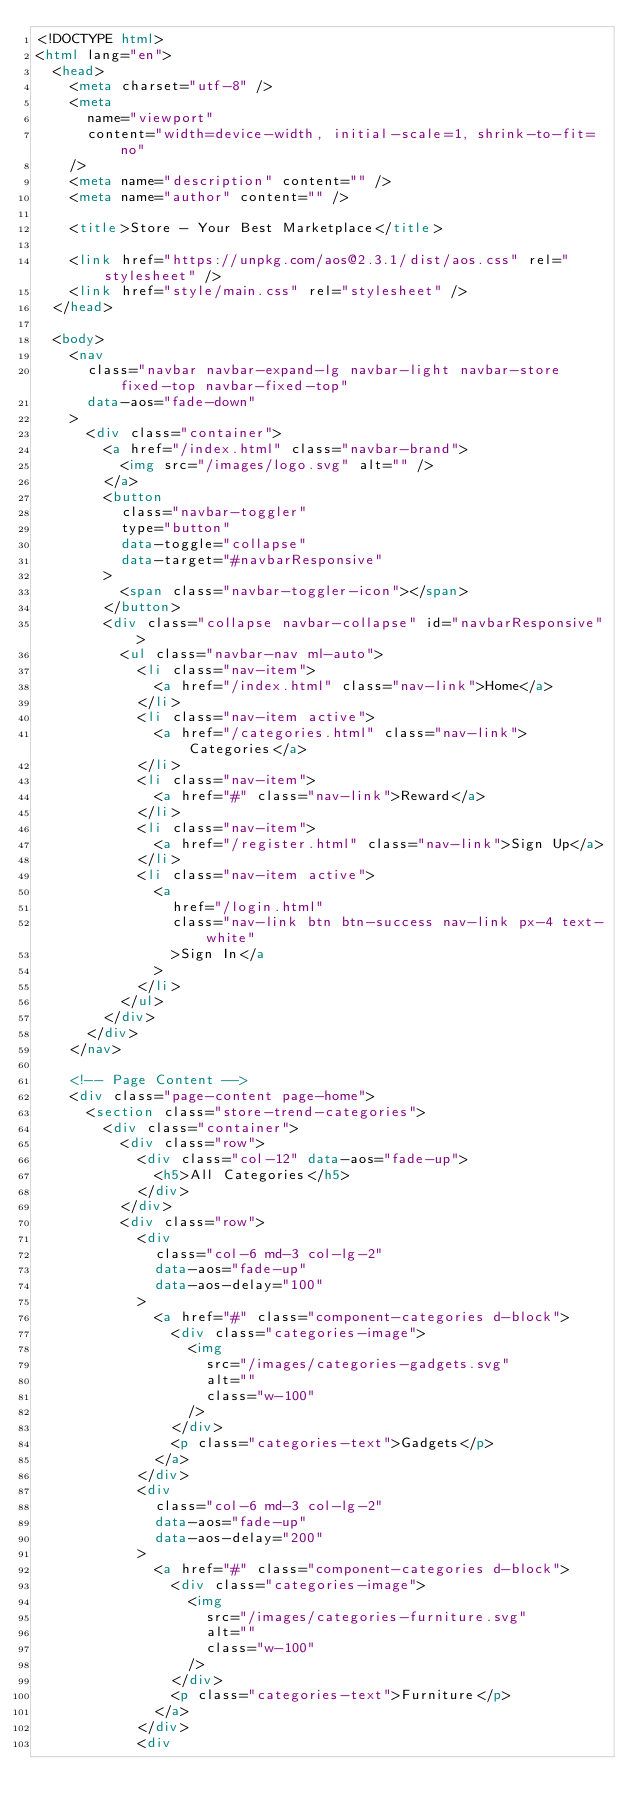Convert code to text. <code><loc_0><loc_0><loc_500><loc_500><_HTML_><!DOCTYPE html>
<html lang="en">
  <head>
    <meta charset="utf-8" />
    <meta
      name="viewport"
      content="width=device-width, initial-scale=1, shrink-to-fit=no"
    />
    <meta name="description" content="" />
    <meta name="author" content="" />

    <title>Store - Your Best Marketplace</title>

    <link href="https://unpkg.com/aos@2.3.1/dist/aos.css" rel="stylesheet" />
    <link href="style/main.css" rel="stylesheet" />
  </head>

  <body>
    <nav
      class="navbar navbar-expand-lg navbar-light navbar-store fixed-top navbar-fixed-top"
      data-aos="fade-down"
    >
      <div class="container">
        <a href="/index.html" class="navbar-brand">
          <img src="/images/logo.svg" alt="" />
        </a>
        <button
          class="navbar-toggler"
          type="button"
          data-toggle="collapse"
          data-target="#navbarResponsive"
        >
          <span class="navbar-toggler-icon"></span>
        </button>
        <div class="collapse navbar-collapse" id="navbarResponsive">
          <ul class="navbar-nav ml-auto">
            <li class="nav-item">
              <a href="/index.html" class="nav-link">Home</a>
            </li>
            <li class="nav-item active">
              <a href="/categories.html" class="nav-link">Categories</a>
            </li>
            <li class="nav-item">
              <a href="#" class="nav-link">Reward</a>
            </li>
            <li class="nav-item">
              <a href="/register.html" class="nav-link">Sign Up</a>
            </li>
            <li class="nav-item active">
              <a
                href="/login.html"
                class="nav-link btn btn-success nav-link px-4 text-white"
                >Sign In</a
              >
            </li>
          </ul>
        </div>
      </div>
    </nav>

    <!-- Page Content -->
    <div class="page-content page-home">
      <section class="store-trend-categories">
        <div class="container">
          <div class="row">
            <div class="col-12" data-aos="fade-up">
              <h5>All Categories</h5>
            </div>
          </div>
          <div class="row">
            <div
              class="col-6 md-3 col-lg-2"
              data-aos="fade-up"
              data-aos-delay="100"
            >
              <a href="#" class="component-categories d-block">
                <div class="categories-image">
                  <img
                    src="/images/categories-gadgets.svg"
                    alt=""
                    class="w-100"
                  />
                </div>
                <p class="categories-text">Gadgets</p>
              </a>
            </div>
            <div
              class="col-6 md-3 col-lg-2"
              data-aos="fade-up"
              data-aos-delay="200"
            >
              <a href="#" class="component-categories d-block">
                <div class="categories-image">
                  <img
                    src="/images/categories-furniture.svg"
                    alt=""
                    class="w-100"
                  />
                </div>
                <p class="categories-text">Furniture</p>
              </a>
            </div>
            <div</code> 